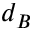Convert formula to latex. <formula><loc_0><loc_0><loc_500><loc_500>d _ { B }</formula> 